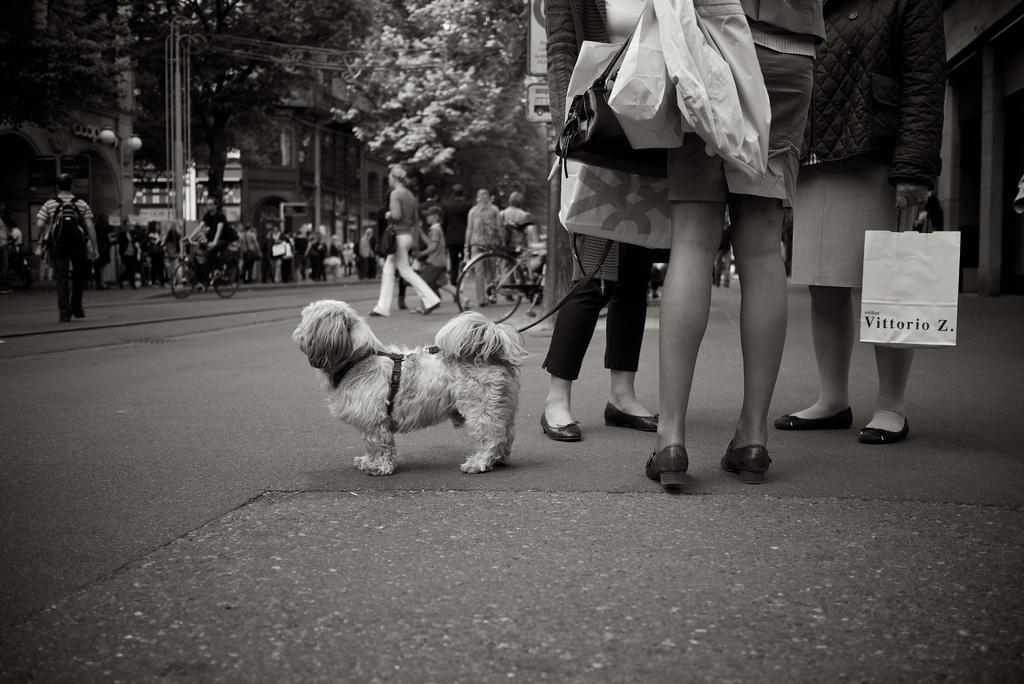Can you describe this image briefly? In this Image I see 3 persons and all of them are holding bags and they are on the path and I see a dog over here. In the background I see number of people who are on the path and there are 2 cycles over here on which there is a man on this cycle and I see the buildings, lights and the trees and there is a board over here. 